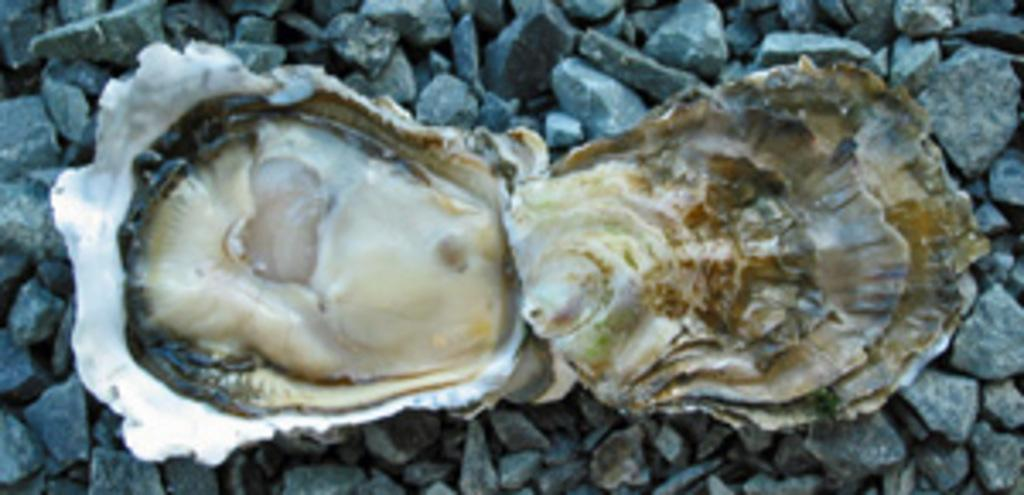What is the main subject in the center of the image? There is a shell in the center of the image. What is the shell resting on? The shell is on stones. How does the shell feel about its minute role in the sky? The shell is not a living being and therefore cannot have feelings or a role in the sky. 